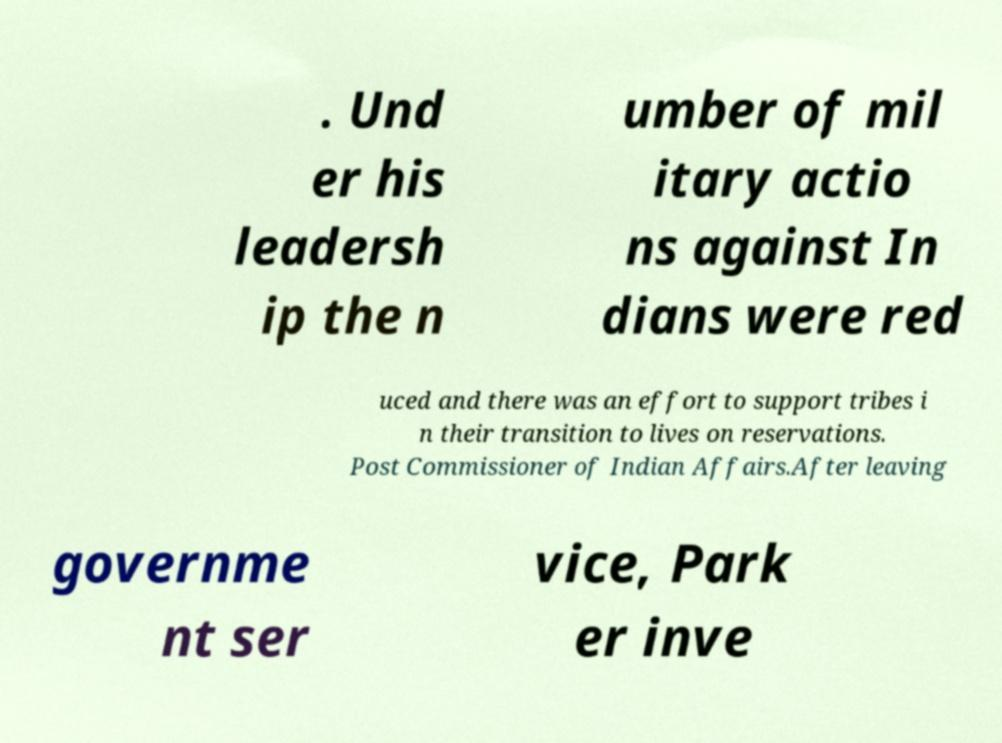Can you read and provide the text displayed in the image?This photo seems to have some interesting text. Can you extract and type it out for me? . Und er his leadersh ip the n umber of mil itary actio ns against In dians were red uced and there was an effort to support tribes i n their transition to lives on reservations. Post Commissioner of Indian Affairs.After leaving governme nt ser vice, Park er inve 